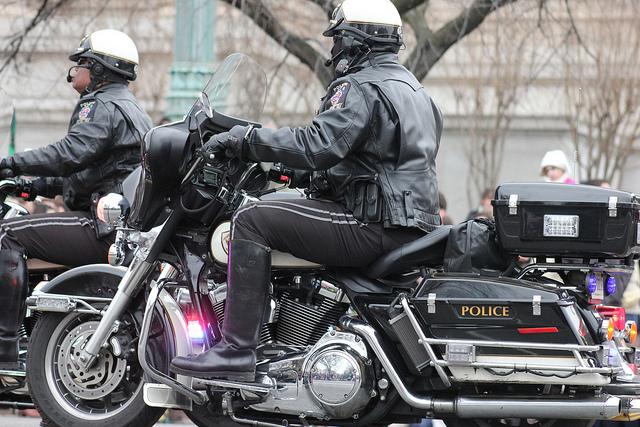How many people who are not police officers are in the picture?
Answer briefly. 1. Is the man riding the bike?
Answer briefly. Yes. Does the officer's boot sole appear to be rubber or wood?
Write a very short answer. Rubber. How many people are in this picture?
Short answer required. 5. How many tires are there?
Quick response, please. 2. How many police are in this photo?
Give a very brief answer. 2. Is anyone riding the motorcycle?
Quick response, please. Yes. Where is the man's bag?
Give a very brief answer. Behind him. 